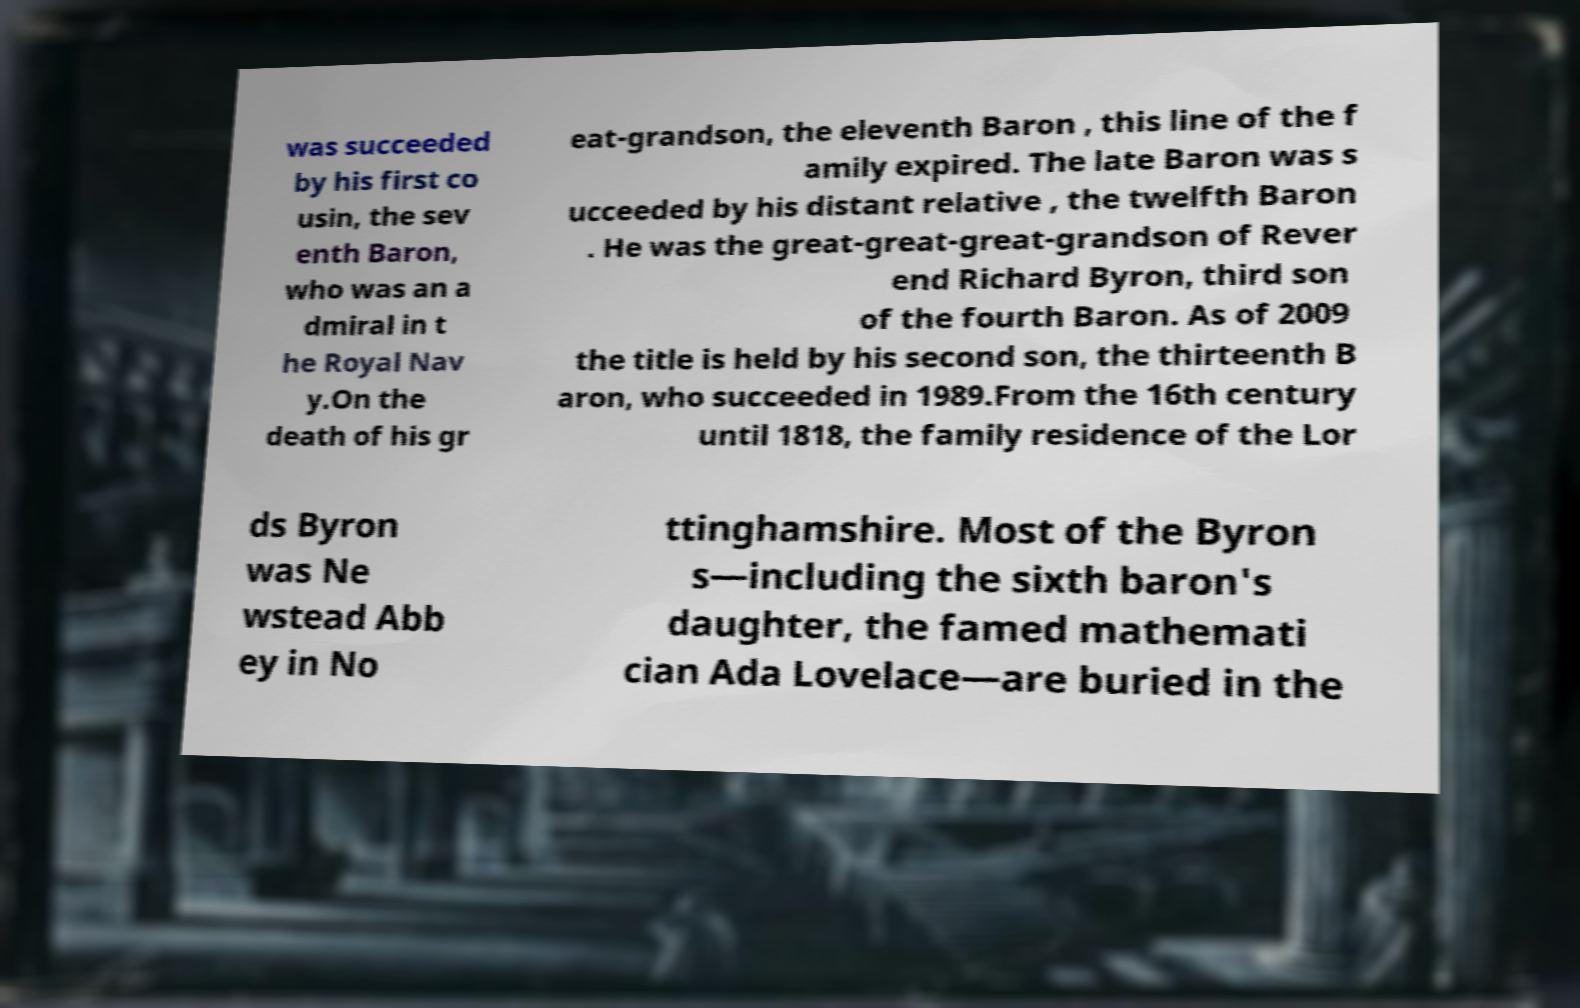Please read and relay the text visible in this image. What does it say? was succeeded by his first co usin, the sev enth Baron, who was an a dmiral in t he Royal Nav y.On the death of his gr eat-grandson, the eleventh Baron , this line of the f amily expired. The late Baron was s ucceeded by his distant relative , the twelfth Baron . He was the great-great-great-grandson of Rever end Richard Byron, third son of the fourth Baron. As of 2009 the title is held by his second son, the thirteenth B aron, who succeeded in 1989.From the 16th century until 1818, the family residence of the Lor ds Byron was Ne wstead Abb ey in No ttinghamshire. Most of the Byron s—including the sixth baron's daughter, the famed mathemati cian Ada Lovelace—are buried in the 